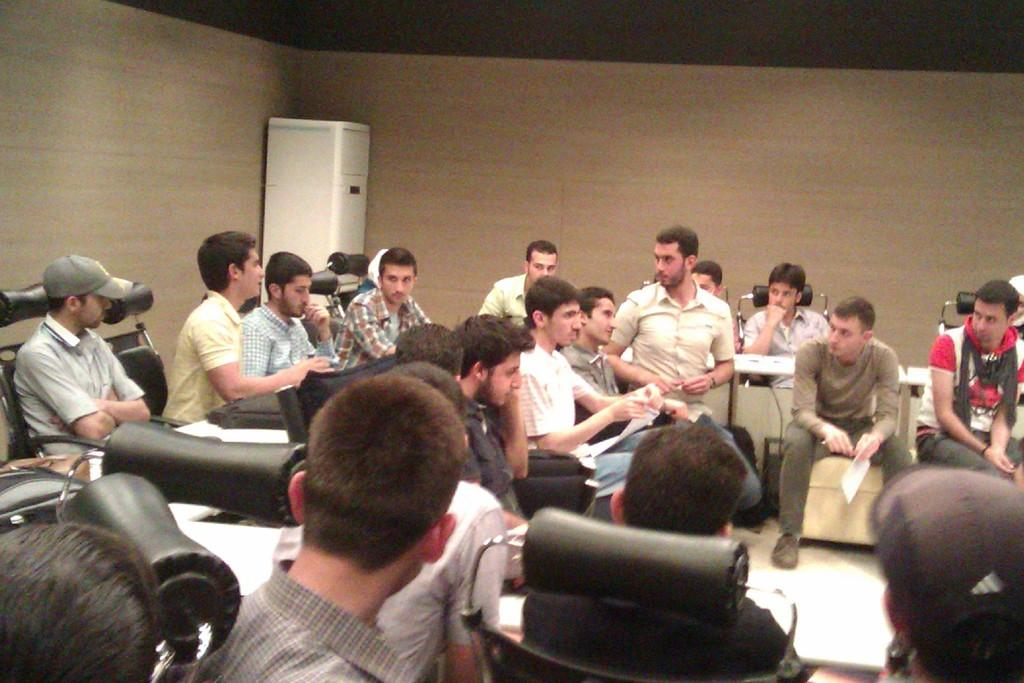What are the people in the image doing? The people in the image are sitting on chairs. What can be seen in the background of the image? There is a wall in the background of the image. What is at the top of the image? There is a ceiling at the top of the image. Can you describe the electronic object in the image? There is a white color electronic object in the image. How does the stranger balance the quartz on their head in the image? There is no stranger or quartz present in the image. 